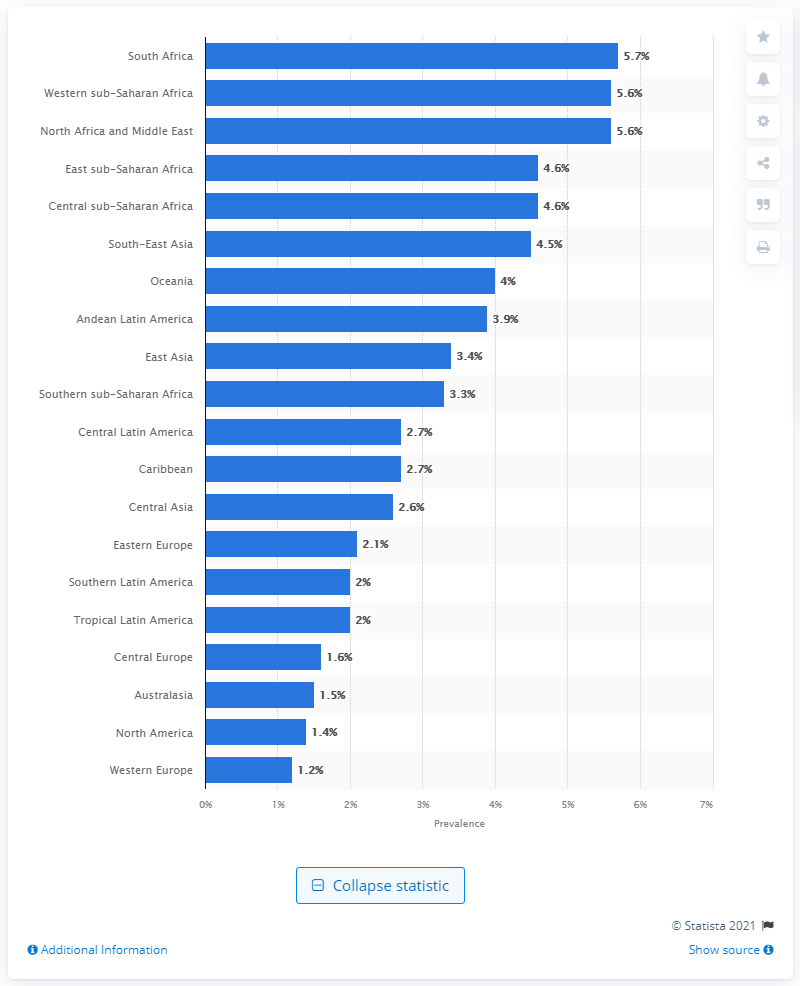Identify some key points in this picture. In 2015, approximately 5.7% of the population of South Africa suffered from blindness or severe visual impairment. 